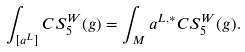<formula> <loc_0><loc_0><loc_500><loc_500>\int _ { [ a ^ { L } ] } C S _ { 5 } ^ { W } ( g ) = \int _ { M } a ^ { L , * } C S _ { 5 } ^ { W } ( g ) .</formula> 